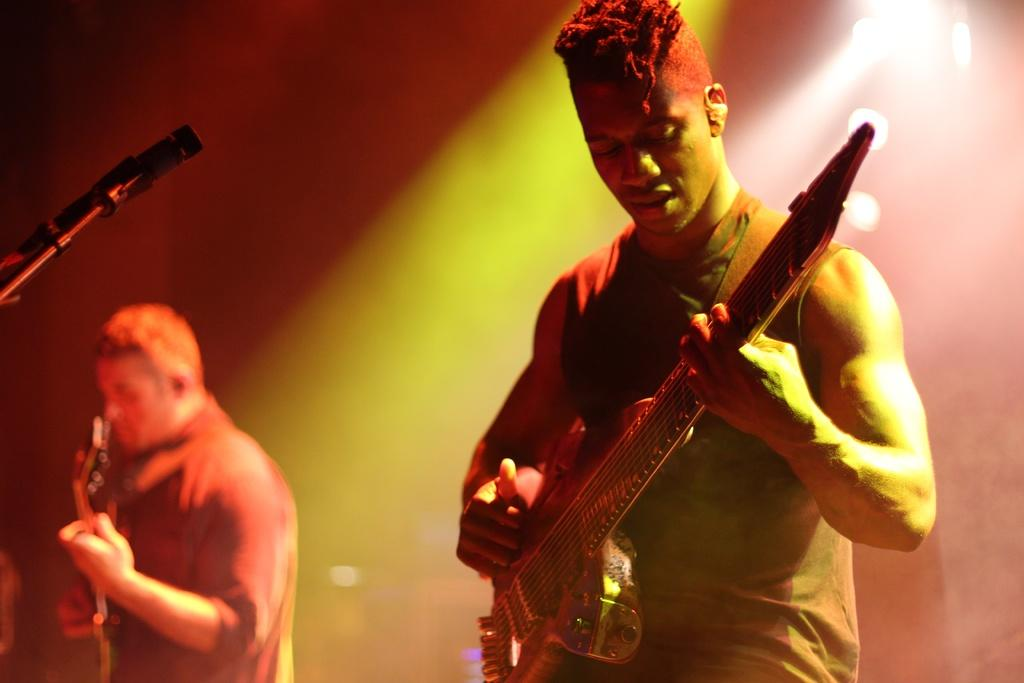How many people are in the image? There are two men in the image. What are the men doing in the image? The men are standing and playing guitar. How are the men holding the guitars? The men are holding the guitars in their hands. What object is in front of the men? There is a microphone in front of the men. What type of light is being used to guide the men in the image? There is no mention of any light or guiding element in the image, so it cannot be determined from the image. 